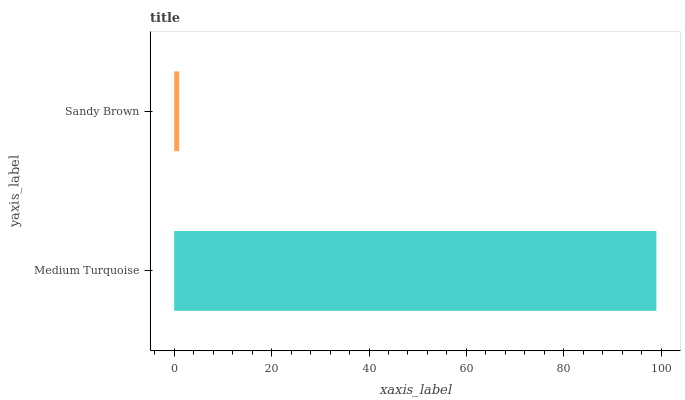Is Sandy Brown the minimum?
Answer yes or no. Yes. Is Medium Turquoise the maximum?
Answer yes or no. Yes. Is Sandy Brown the maximum?
Answer yes or no. No. Is Medium Turquoise greater than Sandy Brown?
Answer yes or no. Yes. Is Sandy Brown less than Medium Turquoise?
Answer yes or no. Yes. Is Sandy Brown greater than Medium Turquoise?
Answer yes or no. No. Is Medium Turquoise less than Sandy Brown?
Answer yes or no. No. Is Medium Turquoise the high median?
Answer yes or no. Yes. Is Sandy Brown the low median?
Answer yes or no. Yes. Is Sandy Brown the high median?
Answer yes or no. No. Is Medium Turquoise the low median?
Answer yes or no. No. 